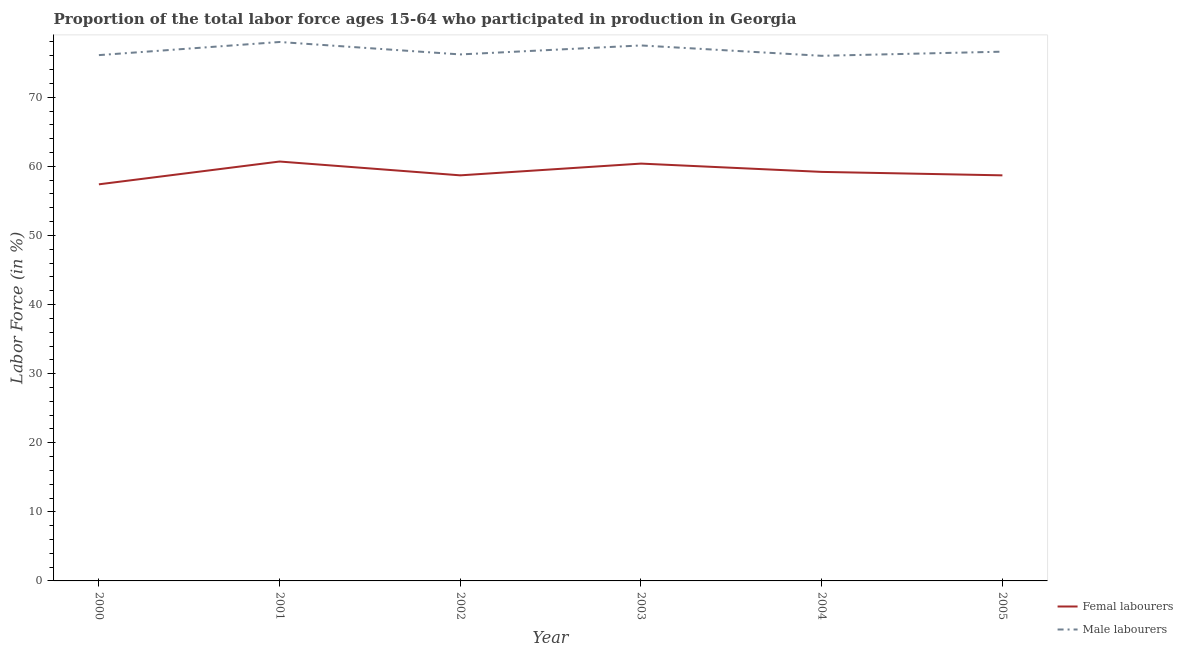How many different coloured lines are there?
Provide a succinct answer. 2. What is the percentage of male labour force in 2002?
Keep it short and to the point. 76.2. Across all years, what is the maximum percentage of female labor force?
Offer a terse response. 60.7. Across all years, what is the minimum percentage of female labor force?
Keep it short and to the point. 57.4. In which year was the percentage of male labour force maximum?
Your response must be concise. 2001. What is the total percentage of female labor force in the graph?
Provide a succinct answer. 355.1. What is the difference between the percentage of female labor force in 2000 and that in 2004?
Your response must be concise. -1.8. What is the difference between the percentage of male labour force in 2005 and the percentage of female labor force in 2003?
Your response must be concise. 16.2. What is the average percentage of male labour force per year?
Your answer should be compact. 76.73. In the year 2000, what is the difference between the percentage of male labour force and percentage of female labor force?
Provide a succinct answer. 18.7. What is the ratio of the percentage of female labor force in 2002 to that in 2003?
Offer a very short reply. 0.97. Is the percentage of male labour force in 2002 less than that in 2003?
Provide a succinct answer. Yes. Is the difference between the percentage of male labour force in 2002 and 2003 greater than the difference between the percentage of female labor force in 2002 and 2003?
Give a very brief answer. Yes. What is the difference between the highest and the second highest percentage of female labor force?
Your response must be concise. 0.3. What is the difference between the highest and the lowest percentage of female labor force?
Give a very brief answer. 3.3. In how many years, is the percentage of female labor force greater than the average percentage of female labor force taken over all years?
Your answer should be very brief. 3. Is the sum of the percentage of male labour force in 2003 and 2004 greater than the maximum percentage of female labor force across all years?
Give a very brief answer. Yes. Does the percentage of male labour force monotonically increase over the years?
Keep it short and to the point. No. Is the percentage of female labor force strictly less than the percentage of male labour force over the years?
Offer a terse response. Yes. How many lines are there?
Your answer should be very brief. 2. How many years are there in the graph?
Give a very brief answer. 6. Does the graph contain any zero values?
Provide a short and direct response. No. Does the graph contain grids?
Your answer should be compact. No. How many legend labels are there?
Ensure brevity in your answer.  2. How are the legend labels stacked?
Ensure brevity in your answer.  Vertical. What is the title of the graph?
Offer a very short reply. Proportion of the total labor force ages 15-64 who participated in production in Georgia. Does "Research and Development" appear as one of the legend labels in the graph?
Make the answer very short. No. What is the label or title of the X-axis?
Offer a very short reply. Year. What is the label or title of the Y-axis?
Make the answer very short. Labor Force (in %). What is the Labor Force (in %) in Femal labourers in 2000?
Your answer should be very brief. 57.4. What is the Labor Force (in %) of Male labourers in 2000?
Ensure brevity in your answer.  76.1. What is the Labor Force (in %) of Femal labourers in 2001?
Your answer should be compact. 60.7. What is the Labor Force (in %) in Femal labourers in 2002?
Offer a very short reply. 58.7. What is the Labor Force (in %) in Male labourers in 2002?
Ensure brevity in your answer.  76.2. What is the Labor Force (in %) in Femal labourers in 2003?
Offer a very short reply. 60.4. What is the Labor Force (in %) in Male labourers in 2003?
Provide a short and direct response. 77.5. What is the Labor Force (in %) in Femal labourers in 2004?
Provide a short and direct response. 59.2. What is the Labor Force (in %) in Male labourers in 2004?
Offer a terse response. 76. What is the Labor Force (in %) of Femal labourers in 2005?
Make the answer very short. 58.7. What is the Labor Force (in %) of Male labourers in 2005?
Ensure brevity in your answer.  76.6. Across all years, what is the maximum Labor Force (in %) in Femal labourers?
Keep it short and to the point. 60.7. Across all years, what is the minimum Labor Force (in %) of Femal labourers?
Offer a terse response. 57.4. Across all years, what is the minimum Labor Force (in %) of Male labourers?
Your answer should be compact. 76. What is the total Labor Force (in %) in Femal labourers in the graph?
Keep it short and to the point. 355.1. What is the total Labor Force (in %) of Male labourers in the graph?
Ensure brevity in your answer.  460.4. What is the difference between the Labor Force (in %) of Femal labourers in 2000 and that in 2001?
Give a very brief answer. -3.3. What is the difference between the Labor Force (in %) of Femal labourers in 2000 and that in 2002?
Keep it short and to the point. -1.3. What is the difference between the Labor Force (in %) in Male labourers in 2000 and that in 2003?
Make the answer very short. -1.4. What is the difference between the Labor Force (in %) in Femal labourers in 2000 and that in 2004?
Give a very brief answer. -1.8. What is the difference between the Labor Force (in %) in Femal labourers in 2000 and that in 2005?
Offer a terse response. -1.3. What is the difference between the Labor Force (in %) of Male labourers in 2000 and that in 2005?
Offer a terse response. -0.5. What is the difference between the Labor Force (in %) of Male labourers in 2001 and that in 2002?
Give a very brief answer. 1.8. What is the difference between the Labor Force (in %) of Femal labourers in 2001 and that in 2003?
Ensure brevity in your answer.  0.3. What is the difference between the Labor Force (in %) in Femal labourers in 2001 and that in 2004?
Your answer should be compact. 1.5. What is the difference between the Labor Force (in %) of Male labourers in 2001 and that in 2004?
Ensure brevity in your answer.  2. What is the difference between the Labor Force (in %) in Femal labourers in 2001 and that in 2005?
Keep it short and to the point. 2. What is the difference between the Labor Force (in %) of Femal labourers in 2002 and that in 2003?
Provide a short and direct response. -1.7. What is the difference between the Labor Force (in %) in Male labourers in 2002 and that in 2004?
Give a very brief answer. 0.2. What is the difference between the Labor Force (in %) of Femal labourers in 2002 and that in 2005?
Your answer should be very brief. 0. What is the difference between the Labor Force (in %) of Male labourers in 2002 and that in 2005?
Offer a terse response. -0.4. What is the difference between the Labor Force (in %) of Femal labourers in 2003 and that in 2004?
Keep it short and to the point. 1.2. What is the difference between the Labor Force (in %) of Male labourers in 2003 and that in 2004?
Your answer should be very brief. 1.5. What is the difference between the Labor Force (in %) of Femal labourers in 2003 and that in 2005?
Offer a terse response. 1.7. What is the difference between the Labor Force (in %) of Male labourers in 2003 and that in 2005?
Your answer should be compact. 0.9. What is the difference between the Labor Force (in %) in Femal labourers in 2000 and the Labor Force (in %) in Male labourers in 2001?
Your answer should be compact. -20.6. What is the difference between the Labor Force (in %) of Femal labourers in 2000 and the Labor Force (in %) of Male labourers in 2002?
Offer a very short reply. -18.8. What is the difference between the Labor Force (in %) of Femal labourers in 2000 and the Labor Force (in %) of Male labourers in 2003?
Make the answer very short. -20.1. What is the difference between the Labor Force (in %) in Femal labourers in 2000 and the Labor Force (in %) in Male labourers in 2004?
Provide a short and direct response. -18.6. What is the difference between the Labor Force (in %) of Femal labourers in 2000 and the Labor Force (in %) of Male labourers in 2005?
Your answer should be very brief. -19.2. What is the difference between the Labor Force (in %) of Femal labourers in 2001 and the Labor Force (in %) of Male labourers in 2002?
Keep it short and to the point. -15.5. What is the difference between the Labor Force (in %) of Femal labourers in 2001 and the Labor Force (in %) of Male labourers in 2003?
Keep it short and to the point. -16.8. What is the difference between the Labor Force (in %) of Femal labourers in 2001 and the Labor Force (in %) of Male labourers in 2004?
Make the answer very short. -15.3. What is the difference between the Labor Force (in %) in Femal labourers in 2001 and the Labor Force (in %) in Male labourers in 2005?
Make the answer very short. -15.9. What is the difference between the Labor Force (in %) of Femal labourers in 2002 and the Labor Force (in %) of Male labourers in 2003?
Your answer should be compact. -18.8. What is the difference between the Labor Force (in %) in Femal labourers in 2002 and the Labor Force (in %) in Male labourers in 2004?
Keep it short and to the point. -17.3. What is the difference between the Labor Force (in %) in Femal labourers in 2002 and the Labor Force (in %) in Male labourers in 2005?
Keep it short and to the point. -17.9. What is the difference between the Labor Force (in %) in Femal labourers in 2003 and the Labor Force (in %) in Male labourers in 2004?
Ensure brevity in your answer.  -15.6. What is the difference between the Labor Force (in %) in Femal labourers in 2003 and the Labor Force (in %) in Male labourers in 2005?
Make the answer very short. -16.2. What is the difference between the Labor Force (in %) of Femal labourers in 2004 and the Labor Force (in %) of Male labourers in 2005?
Offer a terse response. -17.4. What is the average Labor Force (in %) in Femal labourers per year?
Ensure brevity in your answer.  59.18. What is the average Labor Force (in %) of Male labourers per year?
Your answer should be compact. 76.73. In the year 2000, what is the difference between the Labor Force (in %) in Femal labourers and Labor Force (in %) in Male labourers?
Your answer should be compact. -18.7. In the year 2001, what is the difference between the Labor Force (in %) of Femal labourers and Labor Force (in %) of Male labourers?
Ensure brevity in your answer.  -17.3. In the year 2002, what is the difference between the Labor Force (in %) of Femal labourers and Labor Force (in %) of Male labourers?
Offer a very short reply. -17.5. In the year 2003, what is the difference between the Labor Force (in %) of Femal labourers and Labor Force (in %) of Male labourers?
Offer a terse response. -17.1. In the year 2004, what is the difference between the Labor Force (in %) of Femal labourers and Labor Force (in %) of Male labourers?
Your answer should be compact. -16.8. In the year 2005, what is the difference between the Labor Force (in %) of Femal labourers and Labor Force (in %) of Male labourers?
Your answer should be very brief. -17.9. What is the ratio of the Labor Force (in %) in Femal labourers in 2000 to that in 2001?
Your answer should be very brief. 0.95. What is the ratio of the Labor Force (in %) in Male labourers in 2000 to that in 2001?
Keep it short and to the point. 0.98. What is the ratio of the Labor Force (in %) of Femal labourers in 2000 to that in 2002?
Provide a succinct answer. 0.98. What is the ratio of the Labor Force (in %) of Male labourers in 2000 to that in 2002?
Make the answer very short. 1. What is the ratio of the Labor Force (in %) of Femal labourers in 2000 to that in 2003?
Offer a very short reply. 0.95. What is the ratio of the Labor Force (in %) of Male labourers in 2000 to that in 2003?
Your answer should be compact. 0.98. What is the ratio of the Labor Force (in %) in Femal labourers in 2000 to that in 2004?
Ensure brevity in your answer.  0.97. What is the ratio of the Labor Force (in %) in Male labourers in 2000 to that in 2004?
Keep it short and to the point. 1. What is the ratio of the Labor Force (in %) in Femal labourers in 2000 to that in 2005?
Give a very brief answer. 0.98. What is the ratio of the Labor Force (in %) of Male labourers in 2000 to that in 2005?
Your answer should be compact. 0.99. What is the ratio of the Labor Force (in %) in Femal labourers in 2001 to that in 2002?
Provide a short and direct response. 1.03. What is the ratio of the Labor Force (in %) of Male labourers in 2001 to that in 2002?
Give a very brief answer. 1.02. What is the ratio of the Labor Force (in %) of Femal labourers in 2001 to that in 2004?
Ensure brevity in your answer.  1.03. What is the ratio of the Labor Force (in %) in Male labourers in 2001 to that in 2004?
Offer a terse response. 1.03. What is the ratio of the Labor Force (in %) of Femal labourers in 2001 to that in 2005?
Give a very brief answer. 1.03. What is the ratio of the Labor Force (in %) of Male labourers in 2001 to that in 2005?
Your response must be concise. 1.02. What is the ratio of the Labor Force (in %) of Femal labourers in 2002 to that in 2003?
Give a very brief answer. 0.97. What is the ratio of the Labor Force (in %) of Male labourers in 2002 to that in 2003?
Your answer should be very brief. 0.98. What is the ratio of the Labor Force (in %) in Male labourers in 2002 to that in 2004?
Your answer should be very brief. 1. What is the ratio of the Labor Force (in %) in Femal labourers in 2002 to that in 2005?
Your response must be concise. 1. What is the ratio of the Labor Force (in %) in Male labourers in 2002 to that in 2005?
Give a very brief answer. 0.99. What is the ratio of the Labor Force (in %) of Femal labourers in 2003 to that in 2004?
Provide a succinct answer. 1.02. What is the ratio of the Labor Force (in %) in Male labourers in 2003 to that in 2004?
Offer a terse response. 1.02. What is the ratio of the Labor Force (in %) of Male labourers in 2003 to that in 2005?
Provide a short and direct response. 1.01. What is the ratio of the Labor Force (in %) in Femal labourers in 2004 to that in 2005?
Ensure brevity in your answer.  1.01. What is the difference between the highest and the lowest Labor Force (in %) of Femal labourers?
Your answer should be compact. 3.3. What is the difference between the highest and the lowest Labor Force (in %) in Male labourers?
Your answer should be very brief. 2. 